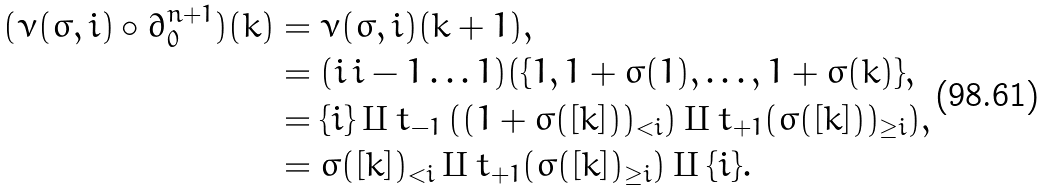<formula> <loc_0><loc_0><loc_500><loc_500>( \nu ( \sigma , i ) \circ \partial _ { 0 } ^ { n + 1 } ) ( k ) & = \nu ( \sigma , i ) ( k + 1 ) , \\ & = ( i \, i - 1 \dots 1 ) ( \{ 1 , 1 + \sigma ( 1 ) , \dots , 1 + \sigma ( k ) \} , \\ & = \{ i \} \amalg t _ { - 1 } \left ( ( 1 + \sigma ( [ k ] ) ) _ { < i } \right ) \amalg t _ { + 1 } ( \sigma ( [ k ] ) ) _ { \geq i } ) , \\ & = \sigma ( [ k ] ) _ { < i } \amalg t _ { + 1 } ( \sigma ( [ k ] ) _ { \geq i } ) \amalg \{ i \} .</formula> 